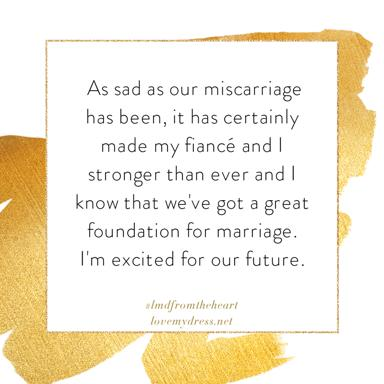What emotional impact does the textual content have when viewed in this particular design setting? Positioned within a gold frame on a white background, the textual content is given a serene and sacred aura, which amplifies the emotional depth. This setting helps in evoking a reflective and hopeful response, inviting viewers to empathize with the shared human experience of overcoming hardships. 